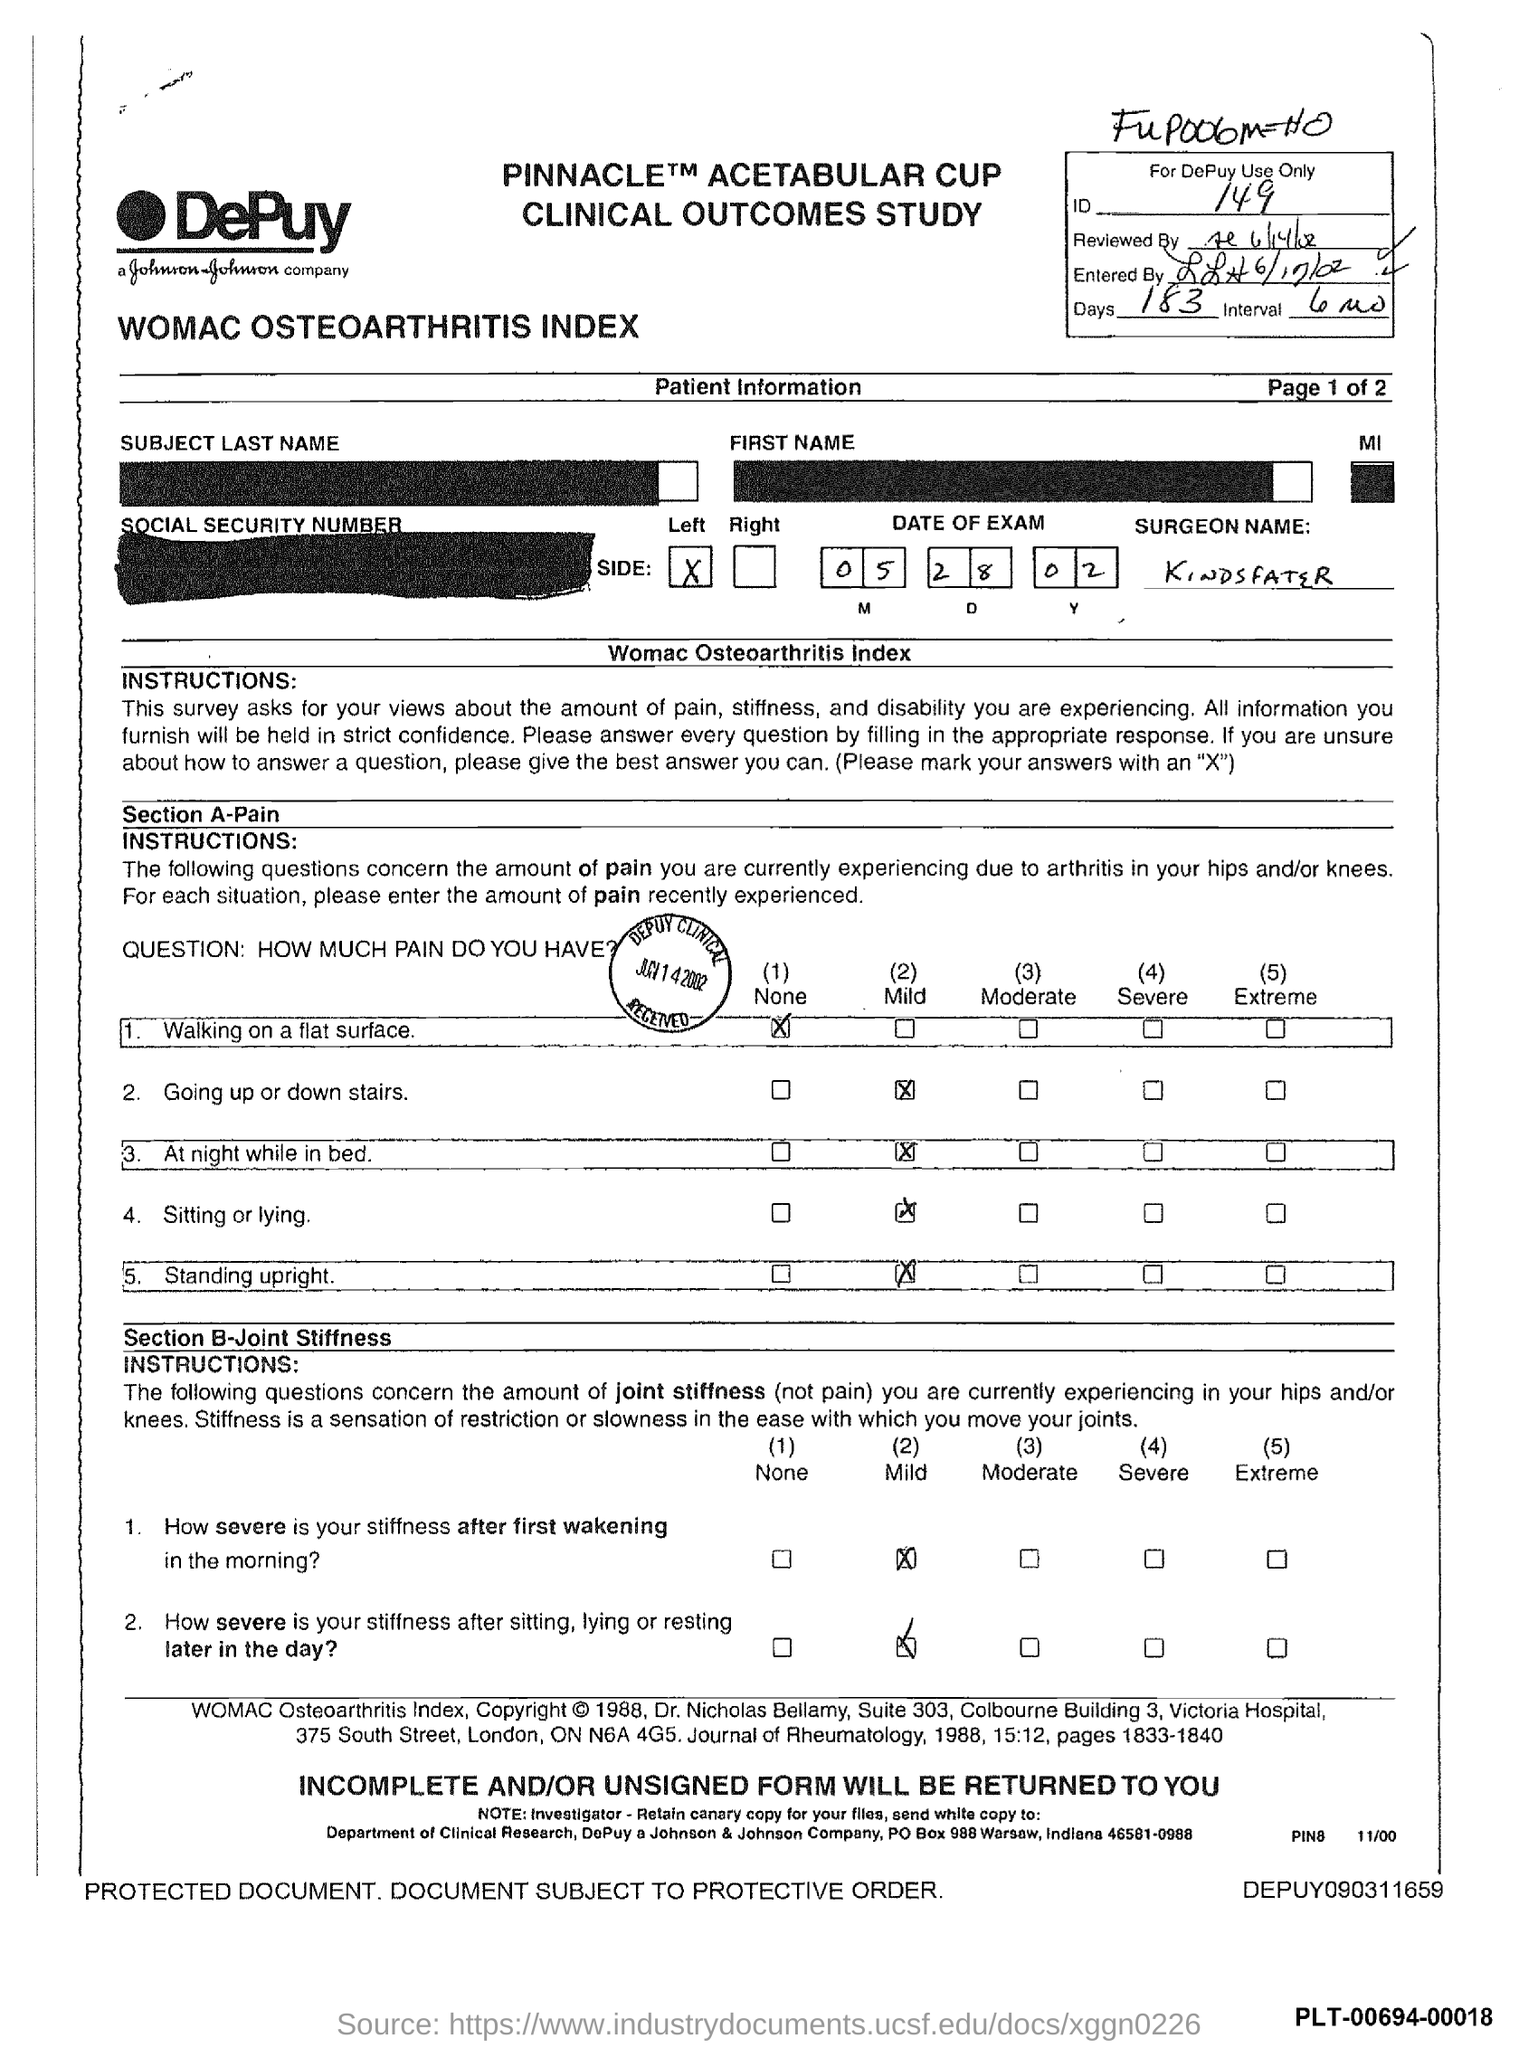What is the ID mentioned in the form?
Ensure brevity in your answer.  149. What is the no of days given in the form?
Ensure brevity in your answer.  183. What is the interval period mentioned in the form?
Provide a short and direct response. 6 Mo. What is the surgeon name mentioned in the form?
Provide a short and direct response. Kindsfater. What is the date of exam given in the form?
Your response must be concise. 05.28.02. 